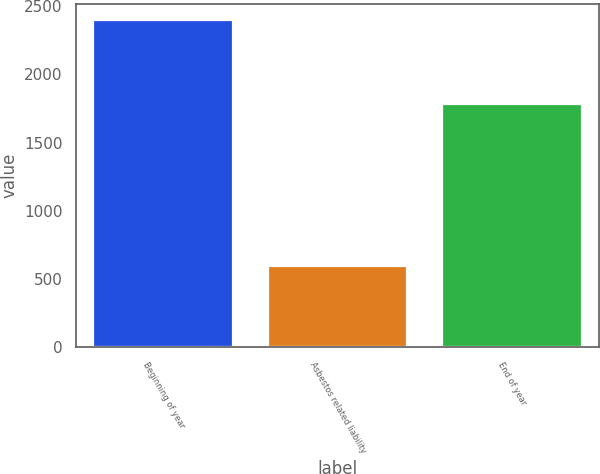Convert chart. <chart><loc_0><loc_0><loc_500><loc_500><bar_chart><fcel>Beginning of year<fcel>Asbestos related liability<fcel>End of year<nl><fcel>2395<fcel>597<fcel>1782<nl></chart> 